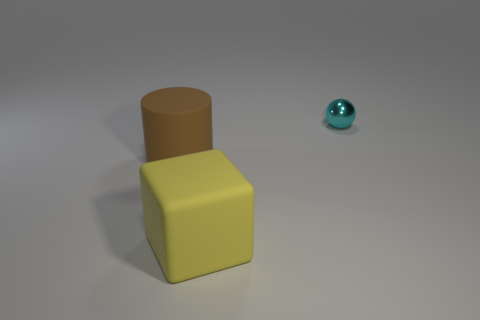There is a large brown cylinder behind the rubber thing to the right of the brown matte object; are there any big brown rubber cylinders that are left of it?
Give a very brief answer. No. Are there any other things that have the same material as the yellow thing?
Provide a succinct answer. Yes. Are any cyan matte cylinders visible?
Keep it short and to the point. No. Does the big block have the same color as the shiny sphere that is on the right side of the large yellow cube?
Your answer should be compact. No. There is a rubber object that is in front of the object that is left of the big object in front of the large rubber cylinder; what size is it?
Offer a terse response. Large. How many objects are tiny shiny balls or things that are on the right side of the large brown rubber object?
Provide a short and direct response. 2. What color is the cylinder?
Give a very brief answer. Brown. The large rubber object that is behind the yellow matte cube is what color?
Offer a very short reply. Brown. There is a big rubber cylinder on the left side of the big yellow object; how many matte things are in front of it?
Offer a very short reply. 1. Does the matte cube have the same size as the object to the right of the large yellow rubber cube?
Provide a succinct answer. No. 